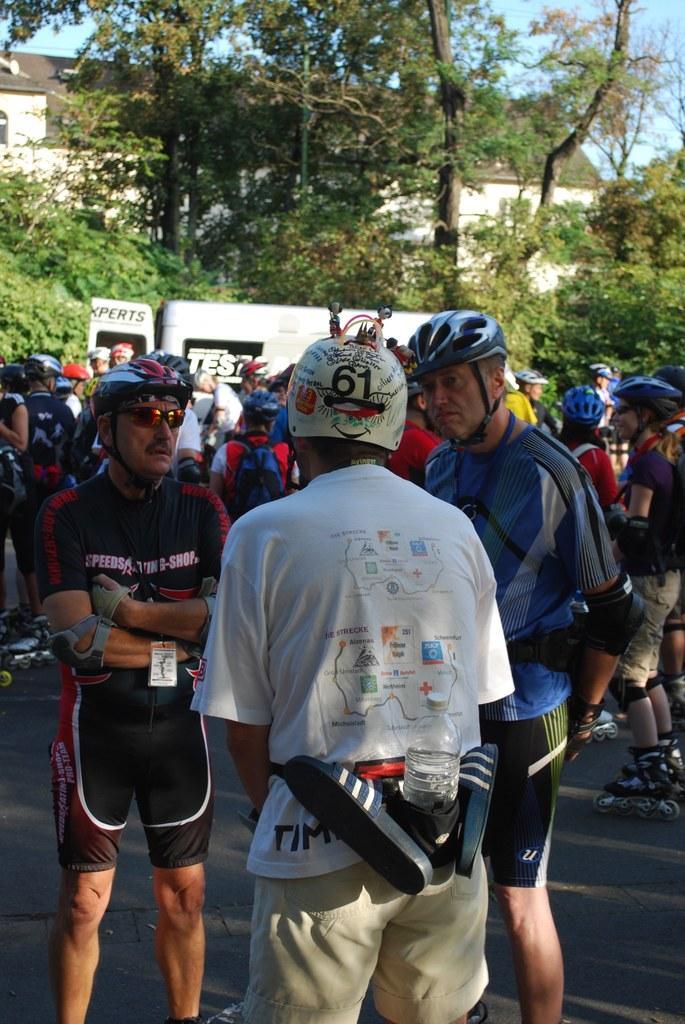In one or two sentences, can you explain what this image depicts? In this image we can see group of people are standing on the road, they are wearing the helmet, there are trees, there is a vehicle on the road, there is a building, at above here is the sky. 